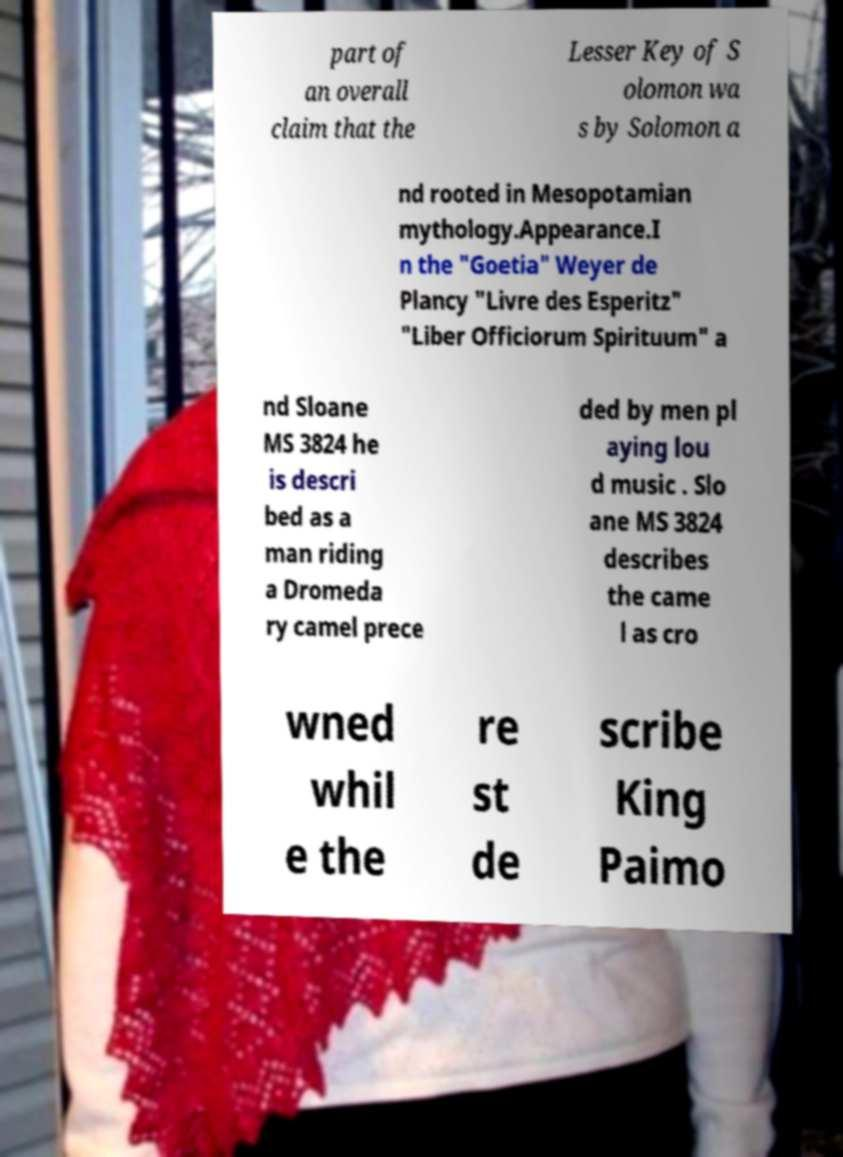I need the written content from this picture converted into text. Can you do that? part of an overall claim that the Lesser Key of S olomon wa s by Solomon a nd rooted in Mesopotamian mythology.Appearance.I n the "Goetia" Weyer de Plancy "Livre des Esperitz" "Liber Officiorum Spirituum" a nd Sloane MS 3824 he is descri bed as a man riding a Dromeda ry camel prece ded by men pl aying lou d music . Slo ane MS 3824 describes the came l as cro wned whil e the re st de scribe King Paimo 